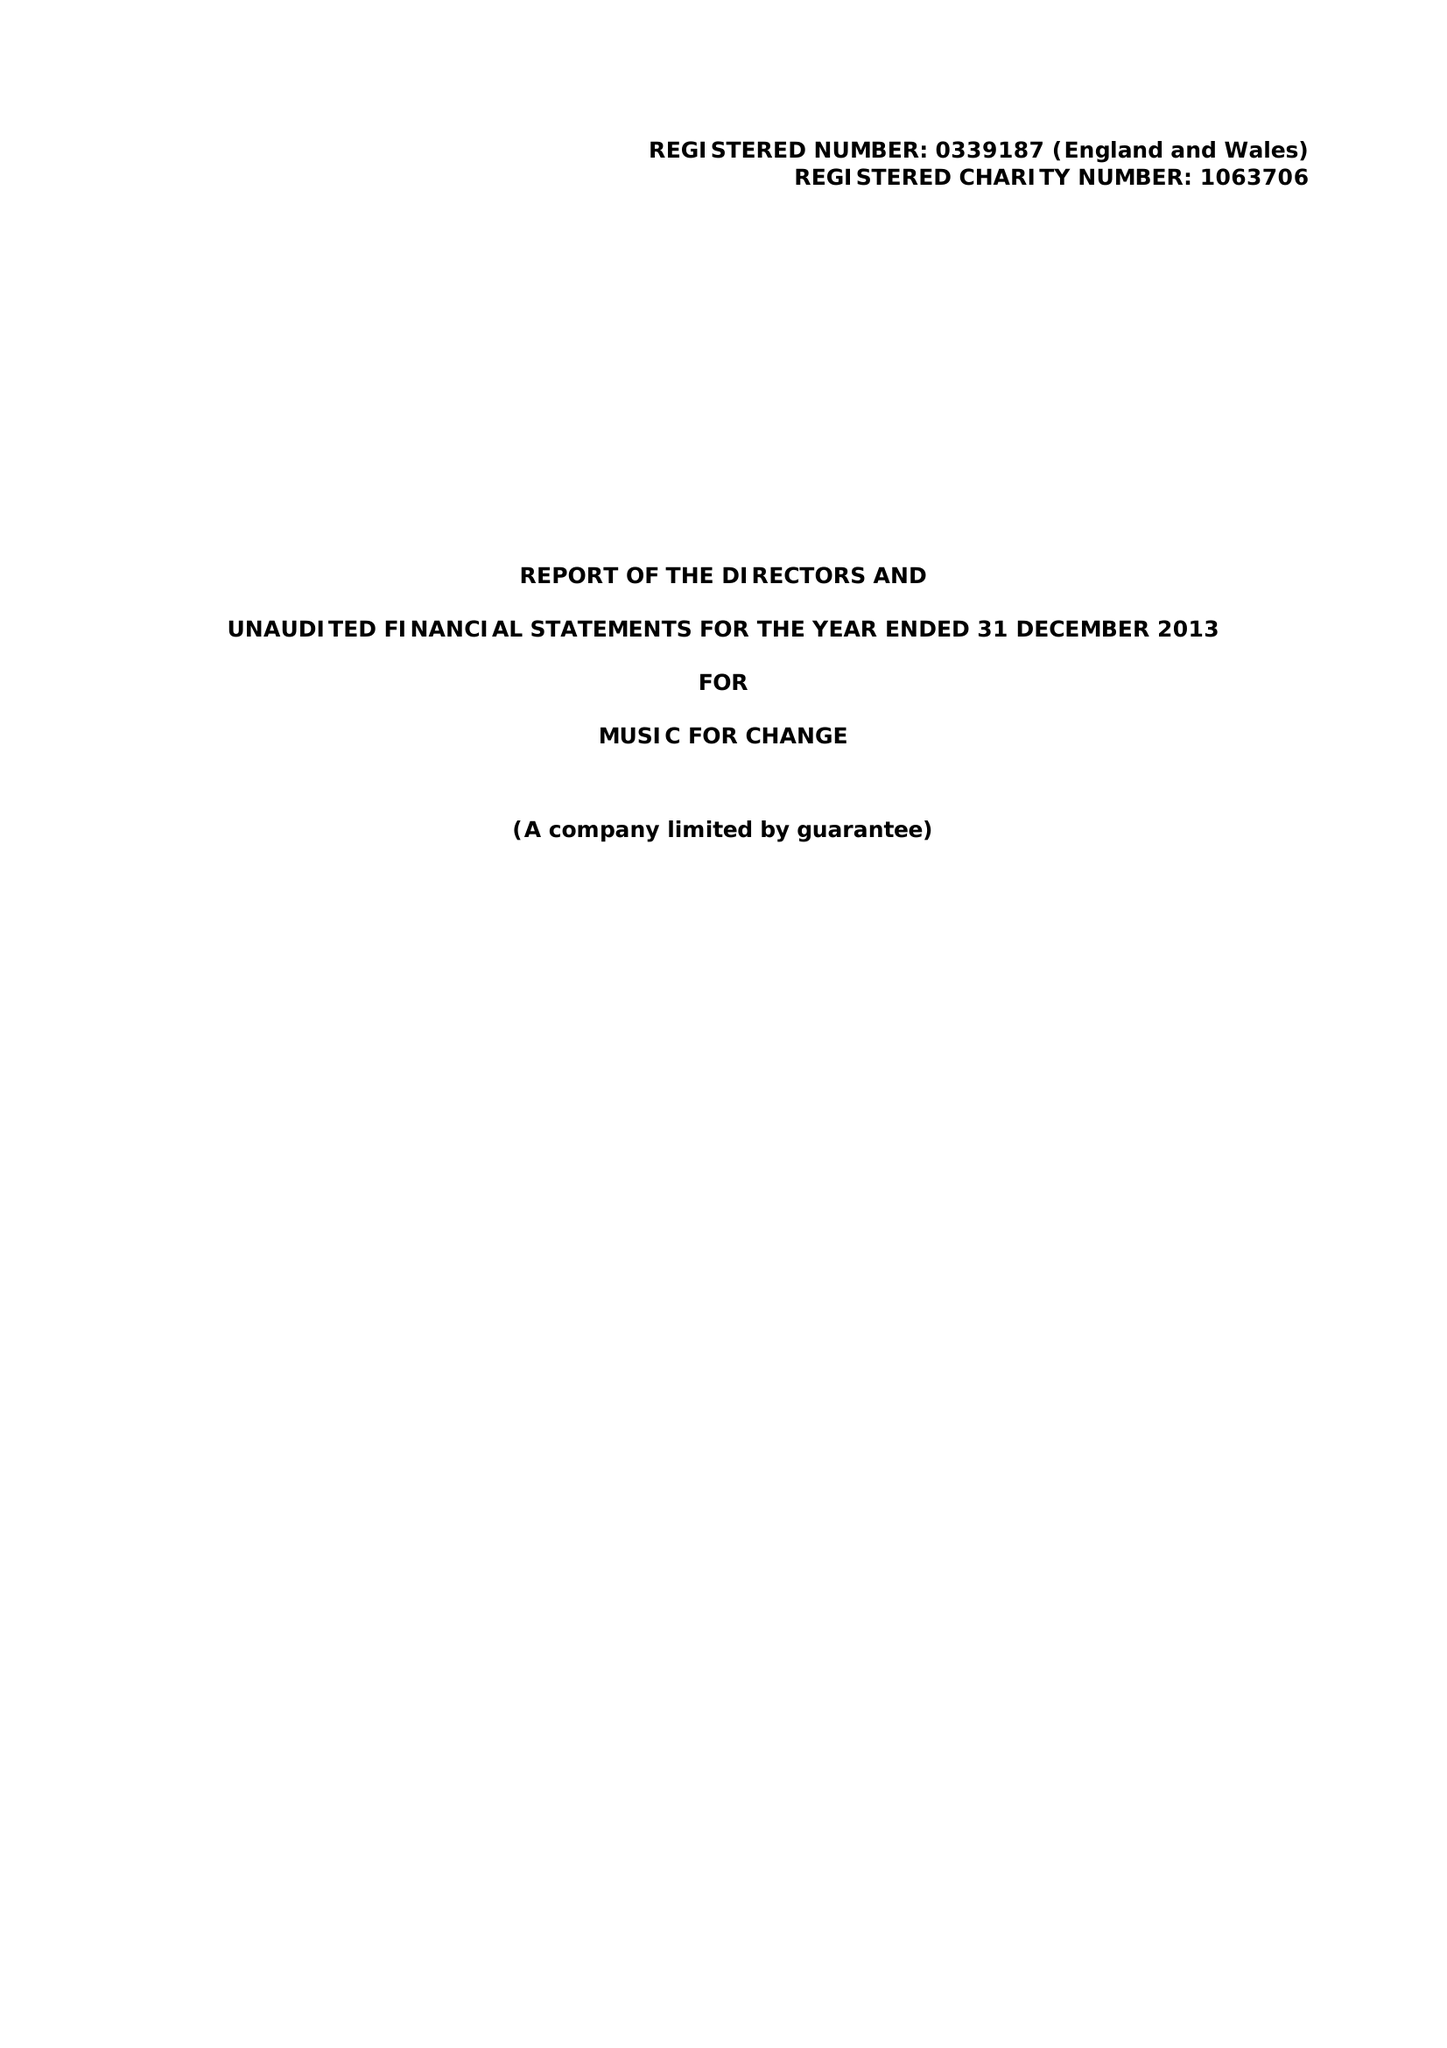What is the value for the charity_name?
Answer the question using a single word or phrase. Music For Change 